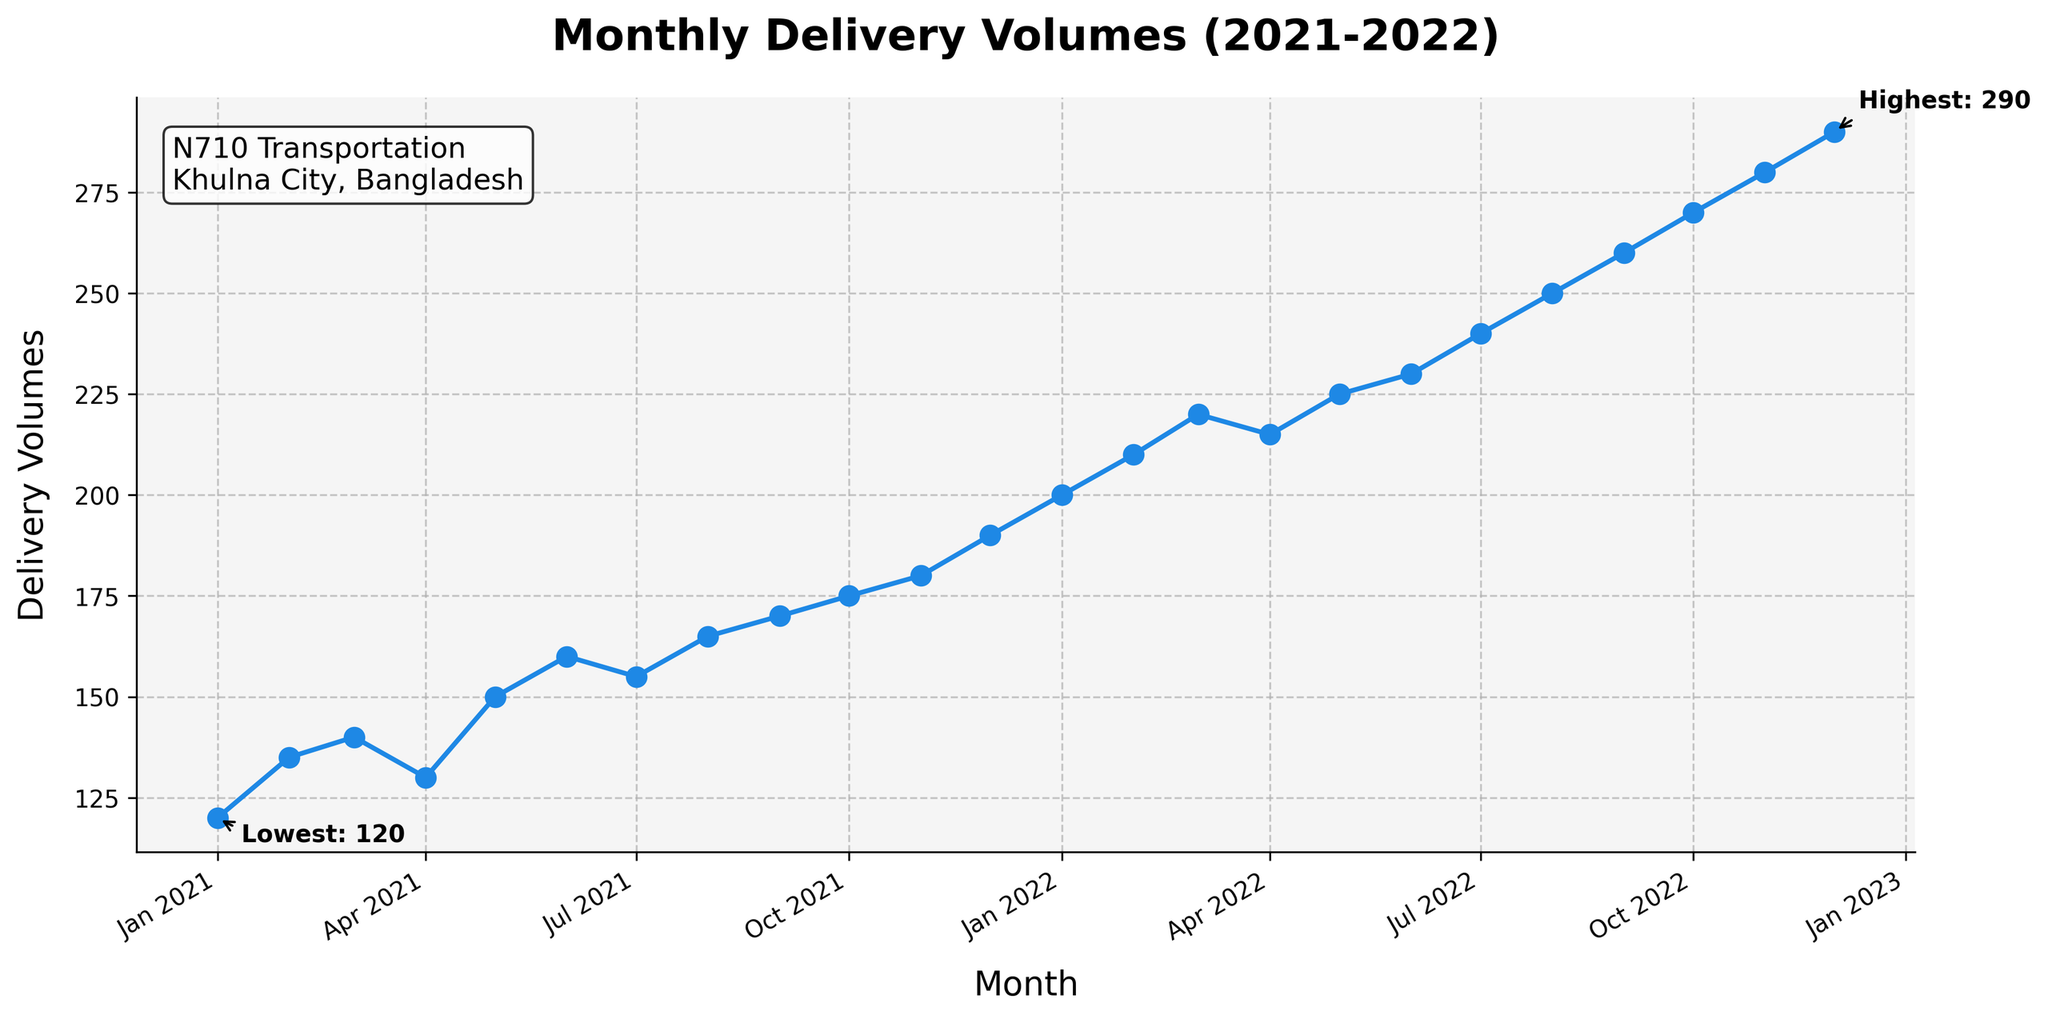What's the title of the plot? The title of the plot is usually located at the top center of the figure. In this case, it reads "Monthly Delivery Volumes (2021-2022)”.
Answer: Monthly Delivery Volumes (2021-2022) What is the highest delivery volume recorded? The plot includes an annotation indicating the highest delivery volume. According to the annotation, the highest delivery volume is 290.
Answer: 290 Which month had the lowest delivery volume and what was the value? The plot has an annotation showing the lowest delivery volume. The annotation indicates that January 2021 had the lowest delivery volume of 120.
Answer: January 2021, 120 How has the delivery volume trend changed from January 2021 to December 2022? Observing the time series, the overall trend shows a steady increase in delivery volumes from January 2021 to December 2022.
Answer: Steady increase How many peaks or local maxima are there in the plot? Peaks or local maxima are points where the volume is higher than the preceding and succeeding data points. The plot shows a steady increase with no distinct local maxima other than the general upward trend.
Answer: None What was the delivery volume in June 2021, and how does it compare to June 2022? By observing the data points for June 2021 and June 2022, it shows the delivery volumes are 160 and 230, respectively. The volume increased by 70 units.
Answer: June 2021: 160, June 2022: 230 What is the average monthly delivery volume across the two years? To find this, sum all the monthly volumes and divide by 24 (the number of months). The average is calculated as (sum of all monthly volumes)/24 = (4575)/24 ≈ 190.625.
Answer: 190.625 Which year saw a higher increase in delivery volumes, 2021 or 2022? By comparing the first and last values of each year, we have January 2021 (120) to December 2021 (190) showing a 70-unit increase. For 2022, January (200) to December (290) shows a 90-unit increase. Hence, 2022 had a higher increase.
Answer: 2022 What is the approximate increase in delivery volumes per month from January 2021 to December 2022? The increase from January 2021 (120) to December 2022 (290) is 290 - 120 = 170. Over 24 months, the approximate increase per month is 170/24 ≈ 7.08 units.
Answer: 7.08 units per month 